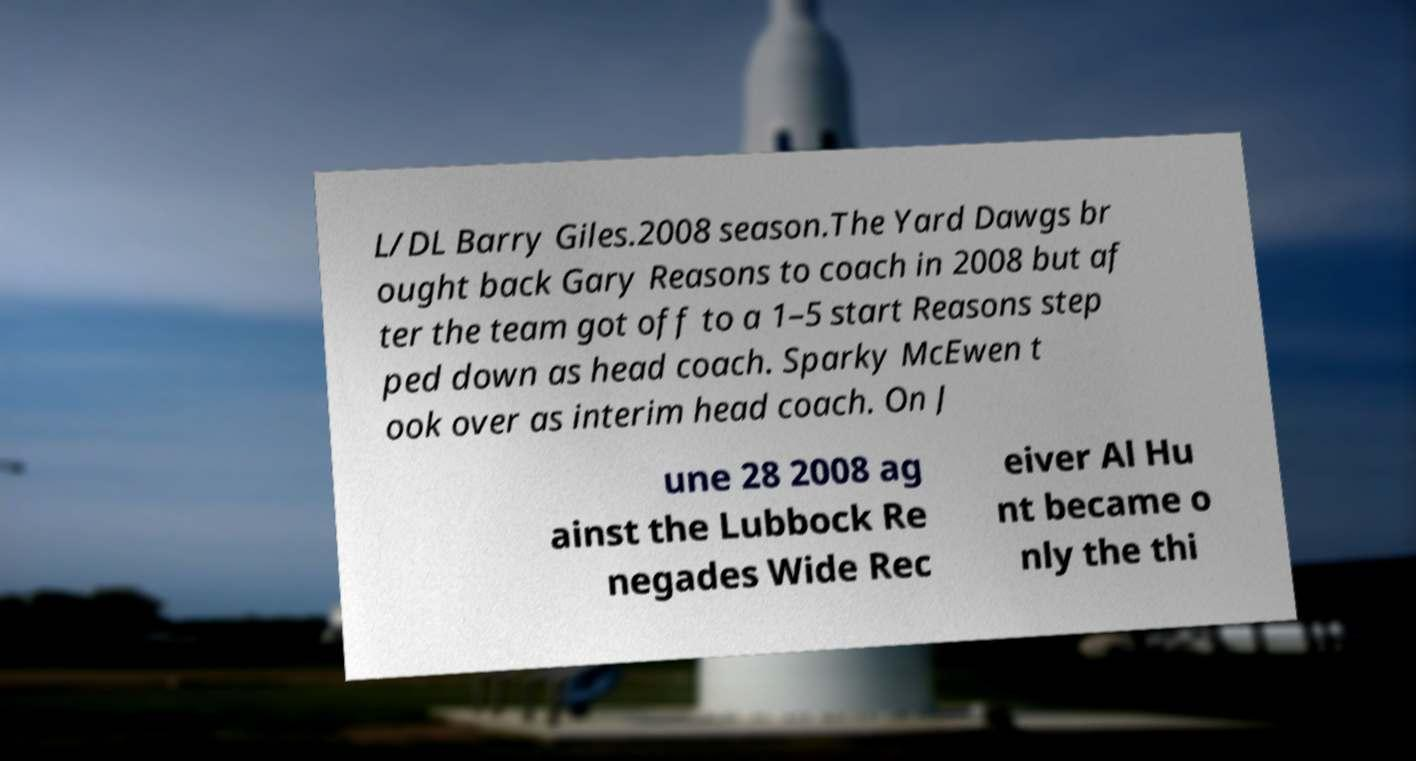I need the written content from this picture converted into text. Can you do that? L/DL Barry Giles.2008 season.The Yard Dawgs br ought back Gary Reasons to coach in 2008 but af ter the team got off to a 1–5 start Reasons step ped down as head coach. Sparky McEwen t ook over as interim head coach. On J une 28 2008 ag ainst the Lubbock Re negades Wide Rec eiver Al Hu nt became o nly the thi 